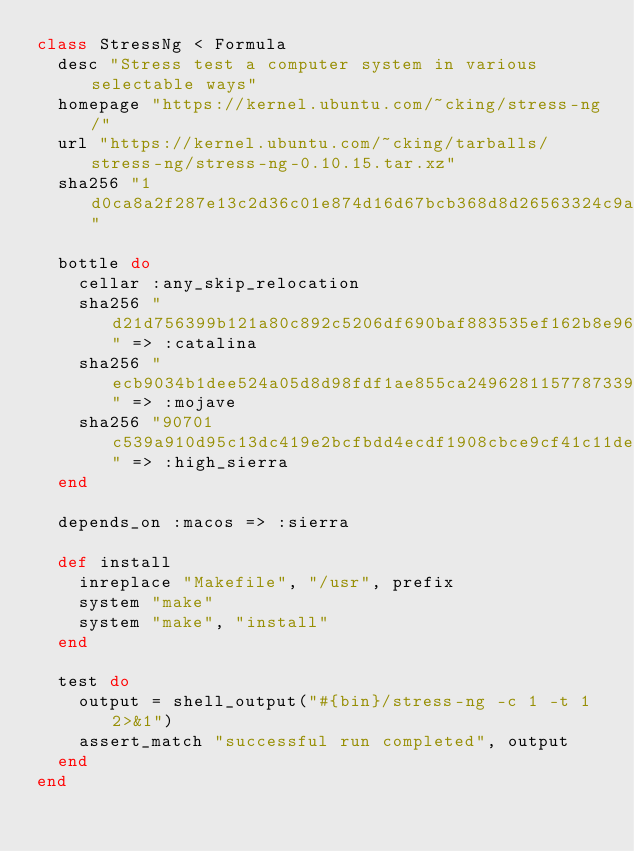Convert code to text. <code><loc_0><loc_0><loc_500><loc_500><_Ruby_>class StressNg < Formula
  desc "Stress test a computer system in various selectable ways"
  homepage "https://kernel.ubuntu.com/~cking/stress-ng/"
  url "https://kernel.ubuntu.com/~cking/tarballs/stress-ng/stress-ng-0.10.15.tar.xz"
  sha256 "1d0ca8a2f287e13c2d36c01e874d16d67bcb368d8d26563324c9aaf0ddb100c1"

  bottle do
    cellar :any_skip_relocation
    sha256 "d21d756399b121a80c892c5206df690baf883535ef162b8e96d83b55f046d187" => :catalina
    sha256 "ecb9034b1dee524a05d8d98fdf1ae855ca2496281157787339ece6eb866afb00" => :mojave
    sha256 "90701c539a910d95c13dc419e2bcfbdd4ecdf1908cbce9cf41c11deb87923558" => :high_sierra
  end

  depends_on :macos => :sierra

  def install
    inreplace "Makefile", "/usr", prefix
    system "make"
    system "make", "install"
  end

  test do
    output = shell_output("#{bin}/stress-ng -c 1 -t 1 2>&1")
    assert_match "successful run completed", output
  end
end
</code> 